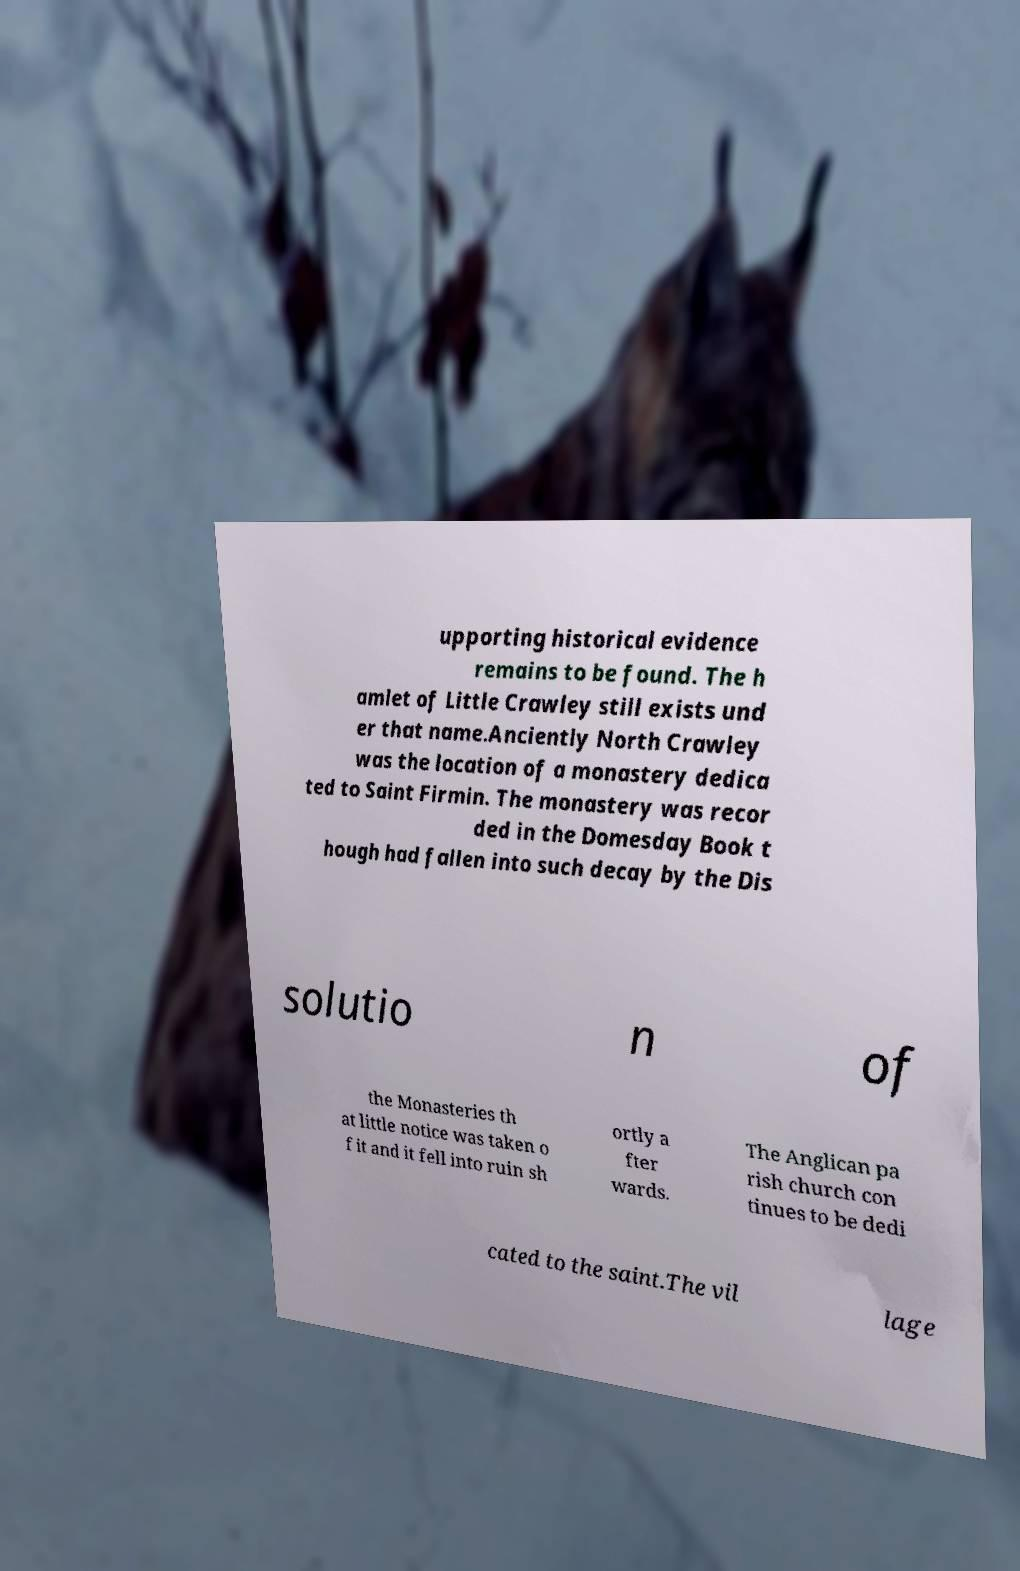Could you extract and type out the text from this image? upporting historical evidence remains to be found. The h amlet of Little Crawley still exists und er that name.Anciently North Crawley was the location of a monastery dedica ted to Saint Firmin. The monastery was recor ded in the Domesday Book t hough had fallen into such decay by the Dis solutio n of the Monasteries th at little notice was taken o f it and it fell into ruin sh ortly a fter wards. The Anglican pa rish church con tinues to be dedi cated to the saint.The vil lage 